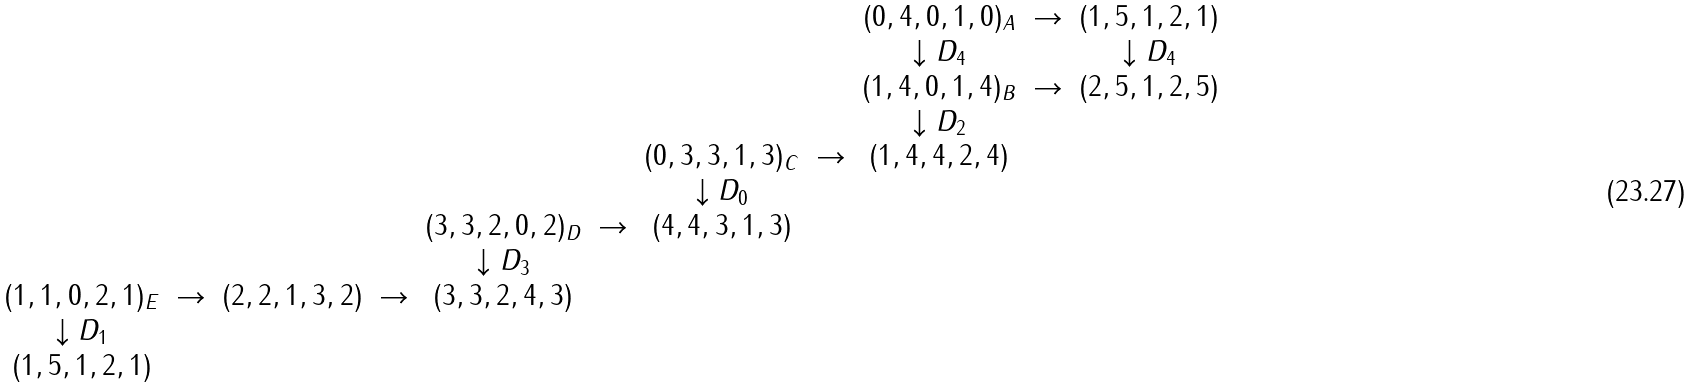<formula> <loc_0><loc_0><loc_500><loc_500>\begin{array} { c c c c c c c c c c c } & & & & & & & & ( 0 , 4 , 0 , 1 , 0 ) _ { A } & \to & ( 1 , 5 , 1 , 2 , 1 ) \\ & & & & & & & & \downarrow D _ { 4 } & & \downarrow D _ { 4 } \\ & & & & & & & & ( 1 , 4 , 0 , 1 , 4 ) _ { B } & \to & ( 2 , 5 , 1 , 2 , 5 ) \\ & & & & & & & & \downarrow D _ { 2 } & & \\ & & & & & & ( 0 , 3 , 3 , 1 , 3 ) _ { C } & \to & ( 1 , 4 , 4 , 2 , 4 ) & & \\ & & & & & & \downarrow D _ { 0 } & & & & \\ & & & & ( 3 , 3 , 2 , 0 , 2 ) _ { D } & \to & ( 4 , 4 , 3 , 1 , 3 ) & & & & \\ & & & & \downarrow D _ { 3 } & & & & & & \\ ( 1 , 1 , 0 , 2 , 1 ) _ { E } & \to & ( 2 , 2 , 1 , 3 , 2 ) & \to & ( 3 , 3 , 2 , 4 , 3 ) & & & & & & \\ \downarrow D _ { 1 } & & & & & & & & & & \\ ( 1 , 5 , 1 , 2 , 1 ) & & & & & & & & & & \end{array}</formula> 